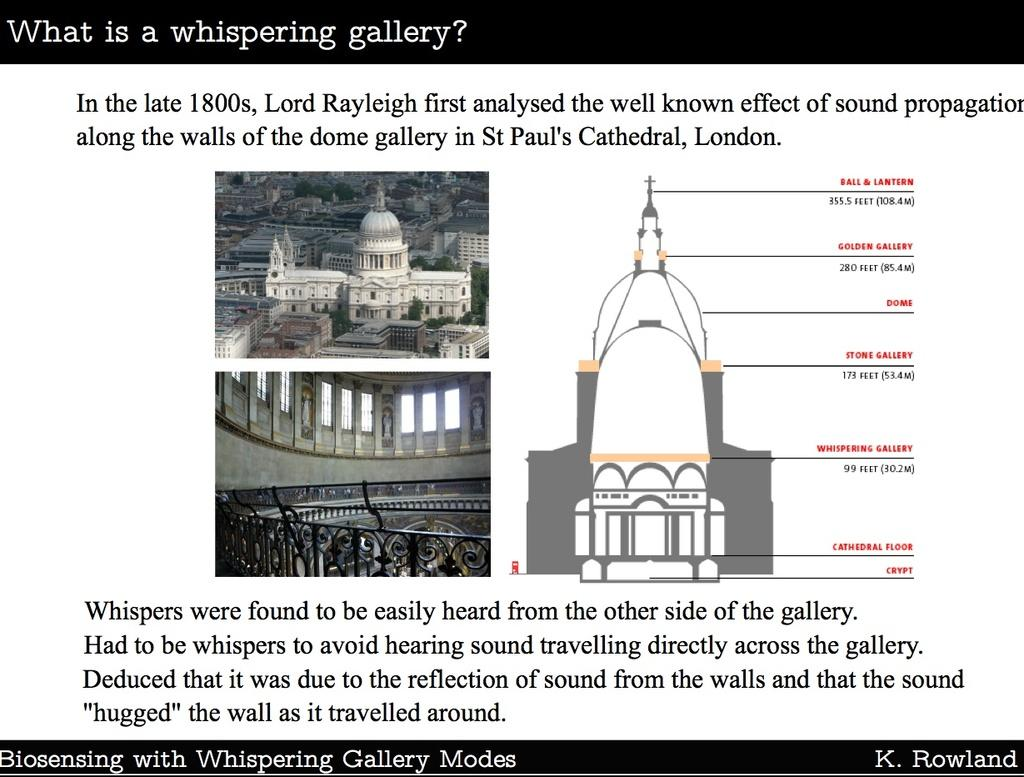<image>
Offer a succinct explanation of the picture presented. A poster offers information about the "whispering gallery" in St. Paul's Cathedral in London. 